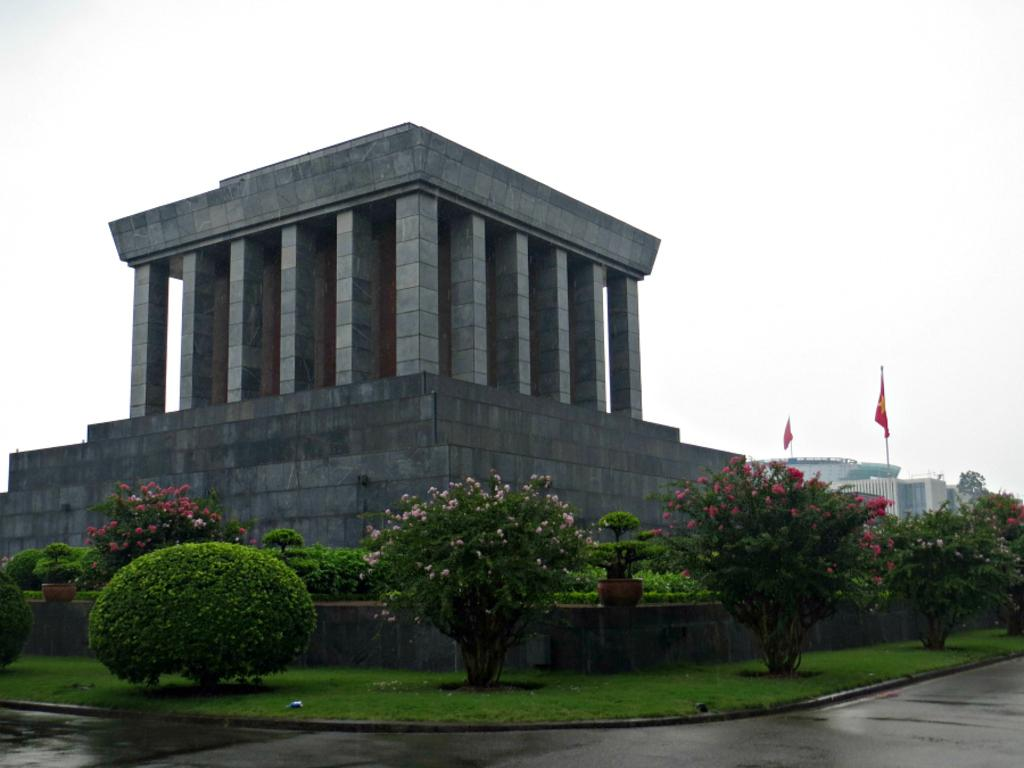What type of structure is visible in the image? There is a roof and pillars in the image, suggesting a building or architectural structure. What can be seen in front of a wall in the image? There are plants in front of a wall in the image, with flowers on them. What is visible in the distance in the image? There is a building visible in the distance. What decorations are present above the building? There are flags above the building. How does the pig contribute to the quiet atmosphere in the image? There is no pig present in the image, so it cannot contribute to the atmosphere. 